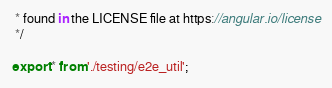<code> <loc_0><loc_0><loc_500><loc_500><_TypeScript_> * found in the LICENSE file at https://angular.io/license
 */

export * from './testing/e2e_util';
</code> 